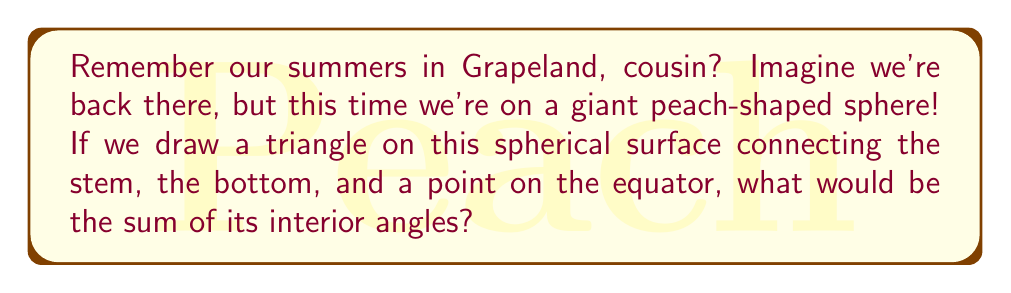Show me your answer to this math problem. Let's approach this step-by-step:

1) In spherical geometry, the sum of angles in a triangle is always greater than 180°. The excess over 180° is directly proportional to the area of the triangle on the sphere's surface.

2) The formula for the sum of angles in a spherical triangle is:

   $$S = \pi + \frac{A}{R^2}$$

   Where $S$ is the sum of angles in radians, $A$ is the area of the triangle, and $R$ is the radius of the sphere.

3) The excess $E$ (in radians) over $\pi$ (180°) is called the spherical excess:

   $$E = \frac{A}{R^2}$$

4) In degrees, the sum of angles can be expressed as:

   $$S_{degrees} = 180° + \frac{A}{R^2} \cdot \frac{180°}{\pi}$$

5) For a triangle connecting the "stem" (North Pole), a point on the equator, and the "bottom" (South Pole), we're dealing with a lune that covers 1/4 of the sphere's surface.

6) The area of this triangle is:

   $$A = \frac{1}{4} \cdot 4\pi R^2 = \pi R^2$$

7) Substituting this into our formula:

   $$S_{degrees} = 180° + \frac{\pi R^2}{R^2} \cdot \frac{180°}{\pi} = 180° + 180° = 360°$$

Thus, the sum of angles in this spherical triangle is 360°.
Answer: 360° 